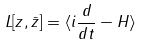<formula> <loc_0><loc_0><loc_500><loc_500>L [ z , \bar { z } ] = \langle i \frac { d } { d t } - H \rangle</formula> 